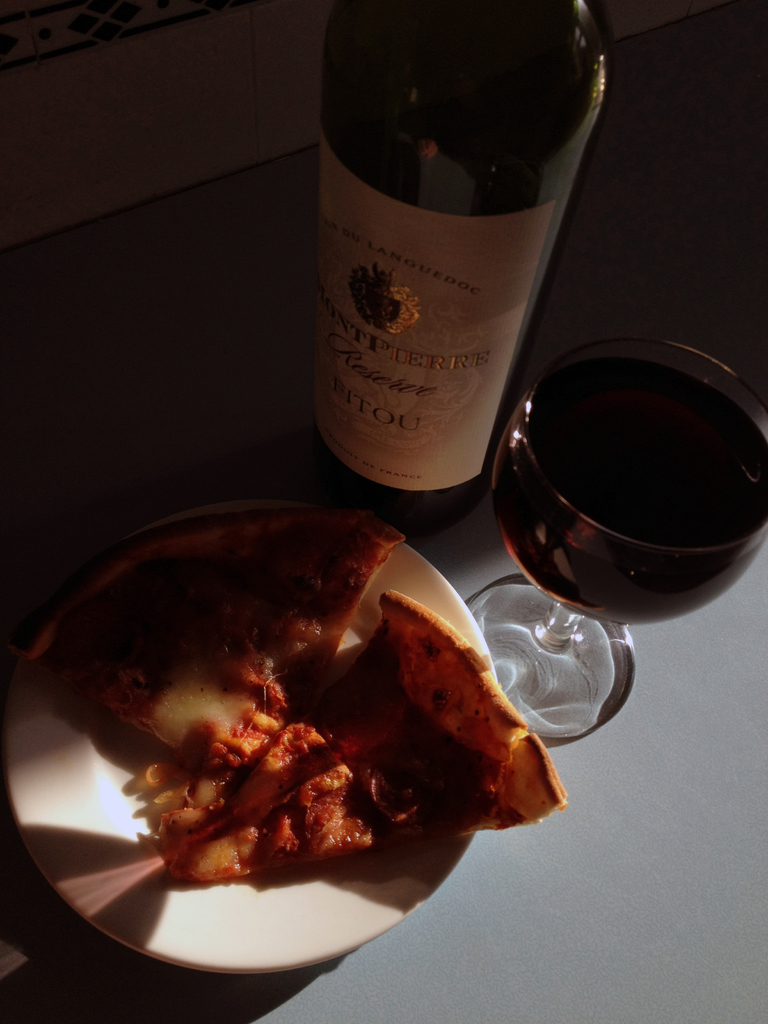What kind of setting does this image suggest, and how does the lighting affect the mood? The setting suggests a casual, cozy dining experience at home, enhanced by the soft, warm light filtering through which adds a relaxed and inviting mood. 